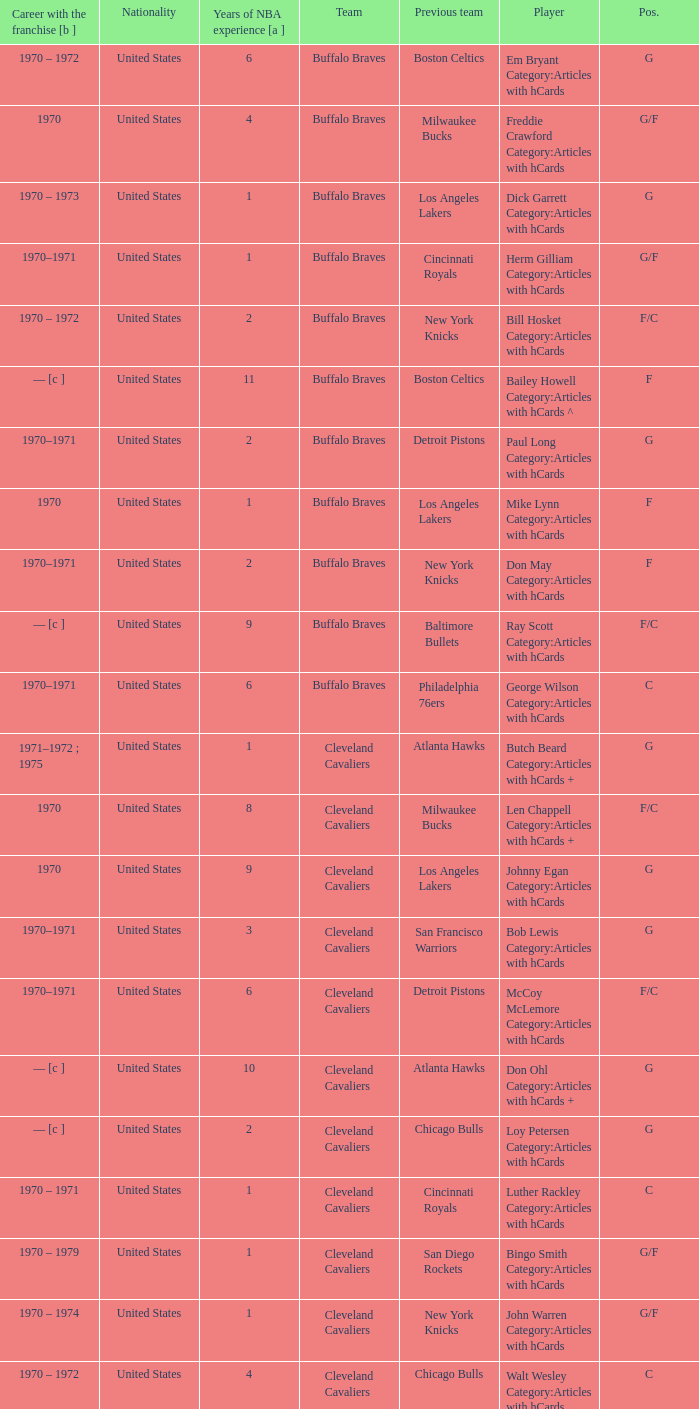Who is the player from the Buffalo Braves with the previous team Los Angeles Lakers and a career with the franchase in 1970? Mike Lynn Category:Articles with hCards. 